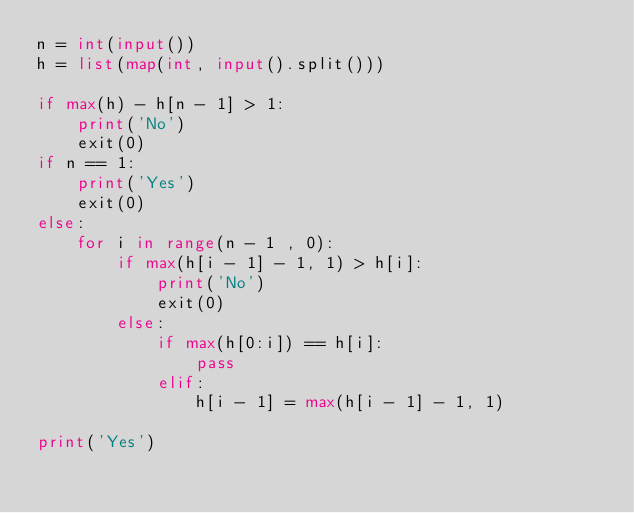<code> <loc_0><loc_0><loc_500><loc_500><_Python_>n = int(input())
h = list(map(int, input().split()))

if max(h) - h[n - 1] > 1:
    print('No')
    exit(0)
if n == 1:
    print('Yes')
    exit(0)
else:
    for i in range(n - 1 , 0):
        if max(h[i - 1] - 1, 1) > h[i]:
            print('No')
            exit(0)
        else:
            if max(h[0:i]) == h[i]:
                pass
            elif:
                h[i - 1] = max(h[i - 1] - 1, 1)

print('Yes')</code> 